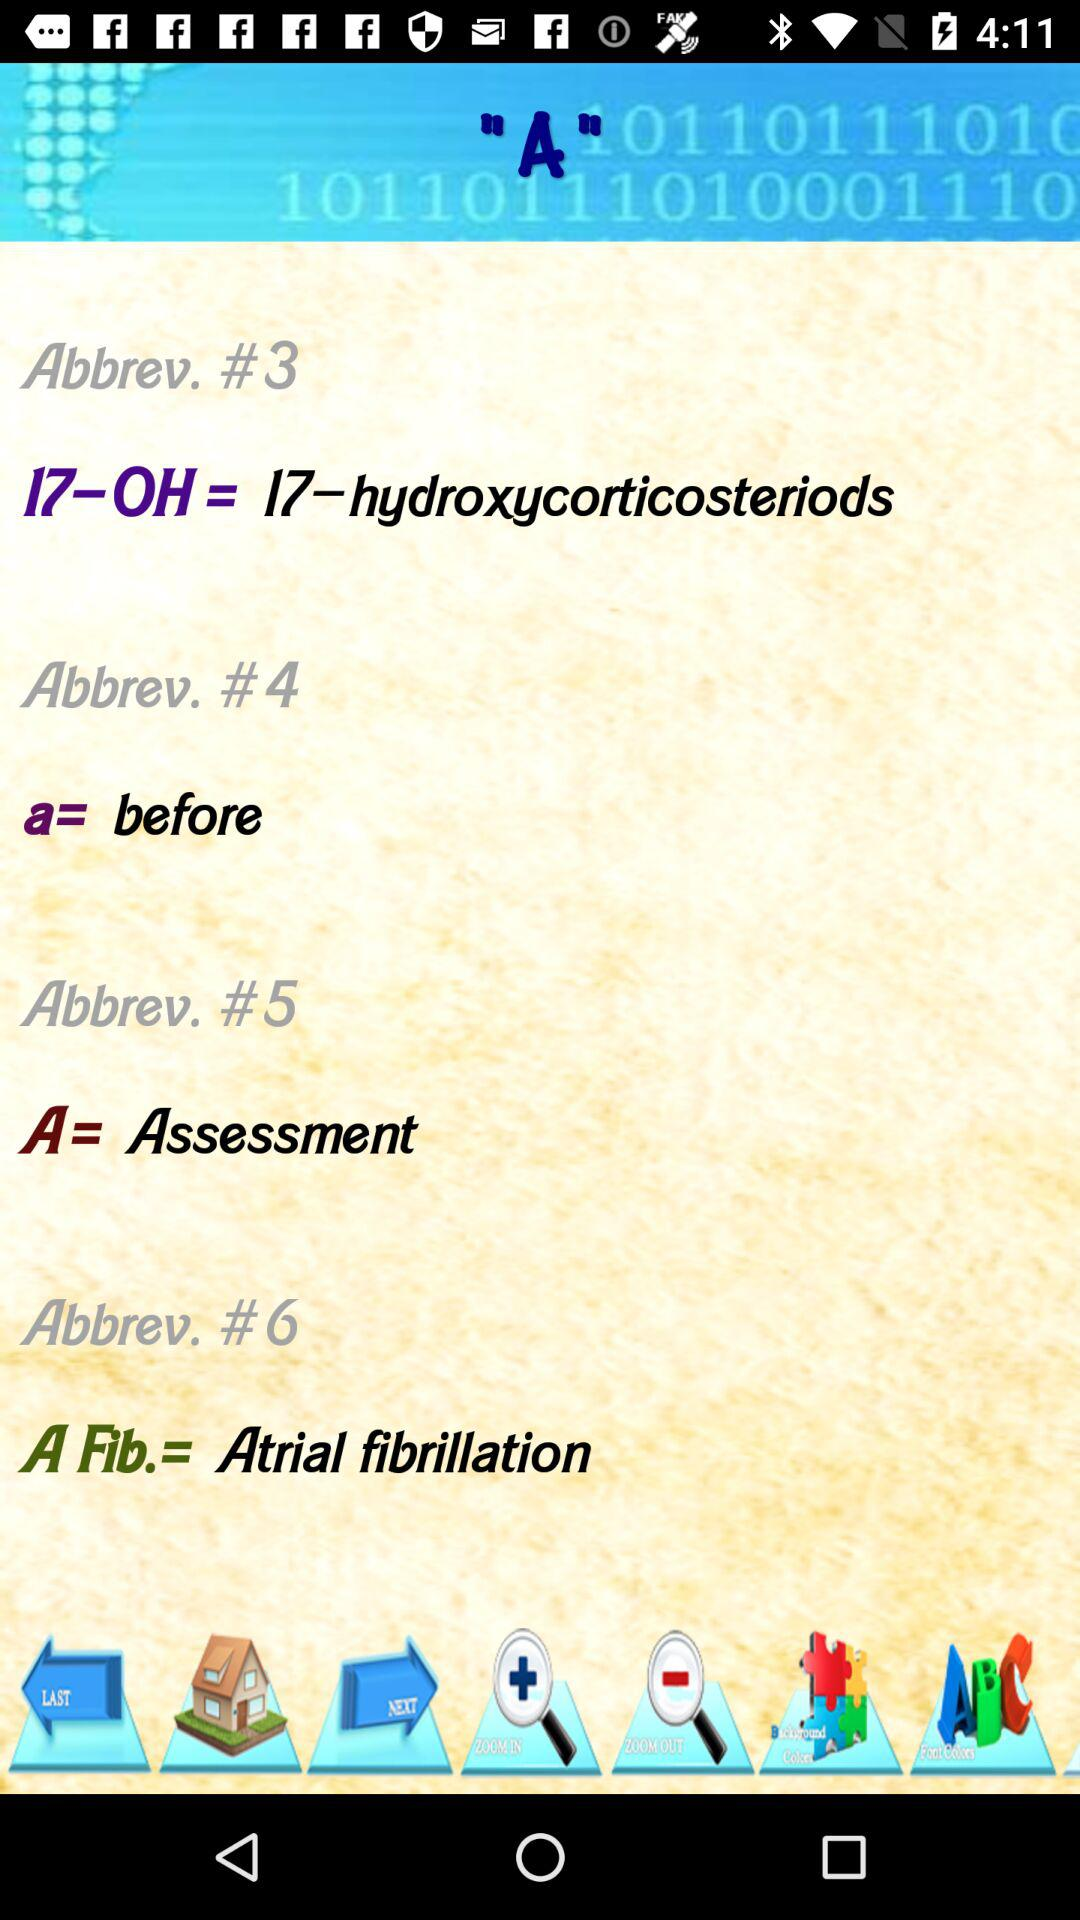What's the full form of A Fib? The full form is atrial fibrillation. 